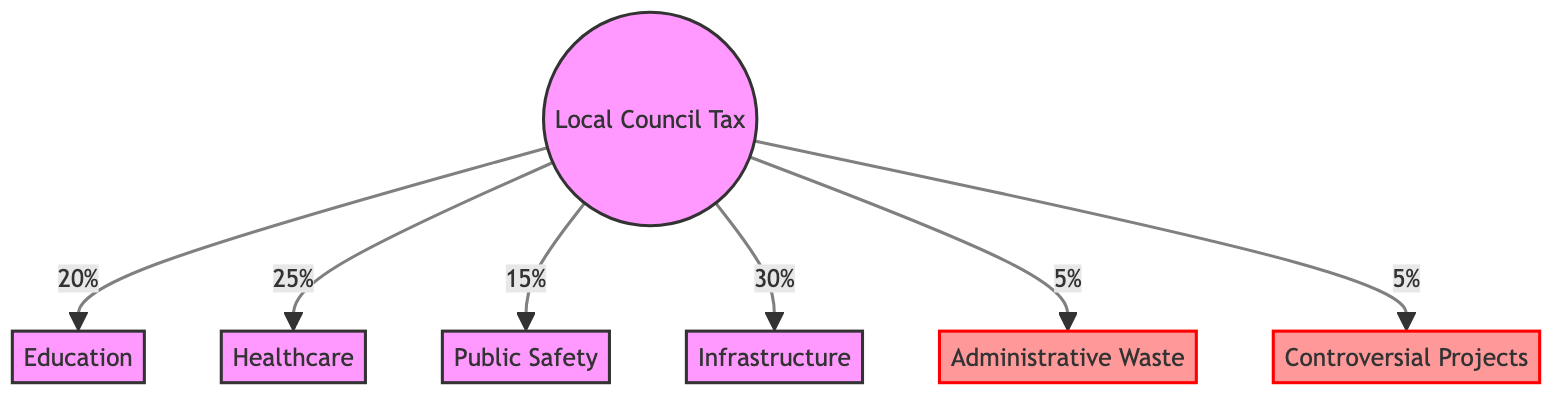What percentage of the Local Council Tax is allocated to education? The diagram shows that education receives 20% of the Local Council Tax.
Answer: 20% What is the waste allocation in percentage? From the diagram, administrative waste and controversial projects both receive 5%, totaling 10% of the Local Council Tax.
Answer: 10% Which sector receives the highest percentage of funding? The diagram indicates that infrastructure receives the highest allocation at 30%.
Answer: Infrastructure How many nodes represent productive spending? The diagram includes four nodes that represent productive spending: education, healthcare, public safety, and infrastructure.
Answer: Four What percentage is spent on public safety? According to the diagram, public safety is allocated 15% of the Local Council Tax.
Answer: 15% What is the total percentage allocated to education and healthcare combined? By adding the percentages shown in the diagram for education (20%) and healthcare (25%), the total is 45%.
Answer: 45% Which type of spending is classified as waste under this diagram? The diagram classifies both administrative waste and controversial projects as waste.
Answer: Administrative Waste and Controversial Projects What is the total percentage of the Local Council Tax spent on unproductive expenditures? The total for unproductive expenditures, consisting of administrative waste (5%) and controversial projects (5%), is 10%.
Answer: 10% Which sector has a lower percentage of funding: healthcare or public safety? The diagram shows that public safety, with 15%, has a lower percentage than healthcare, which is at 25%.
Answer: Public Safety 